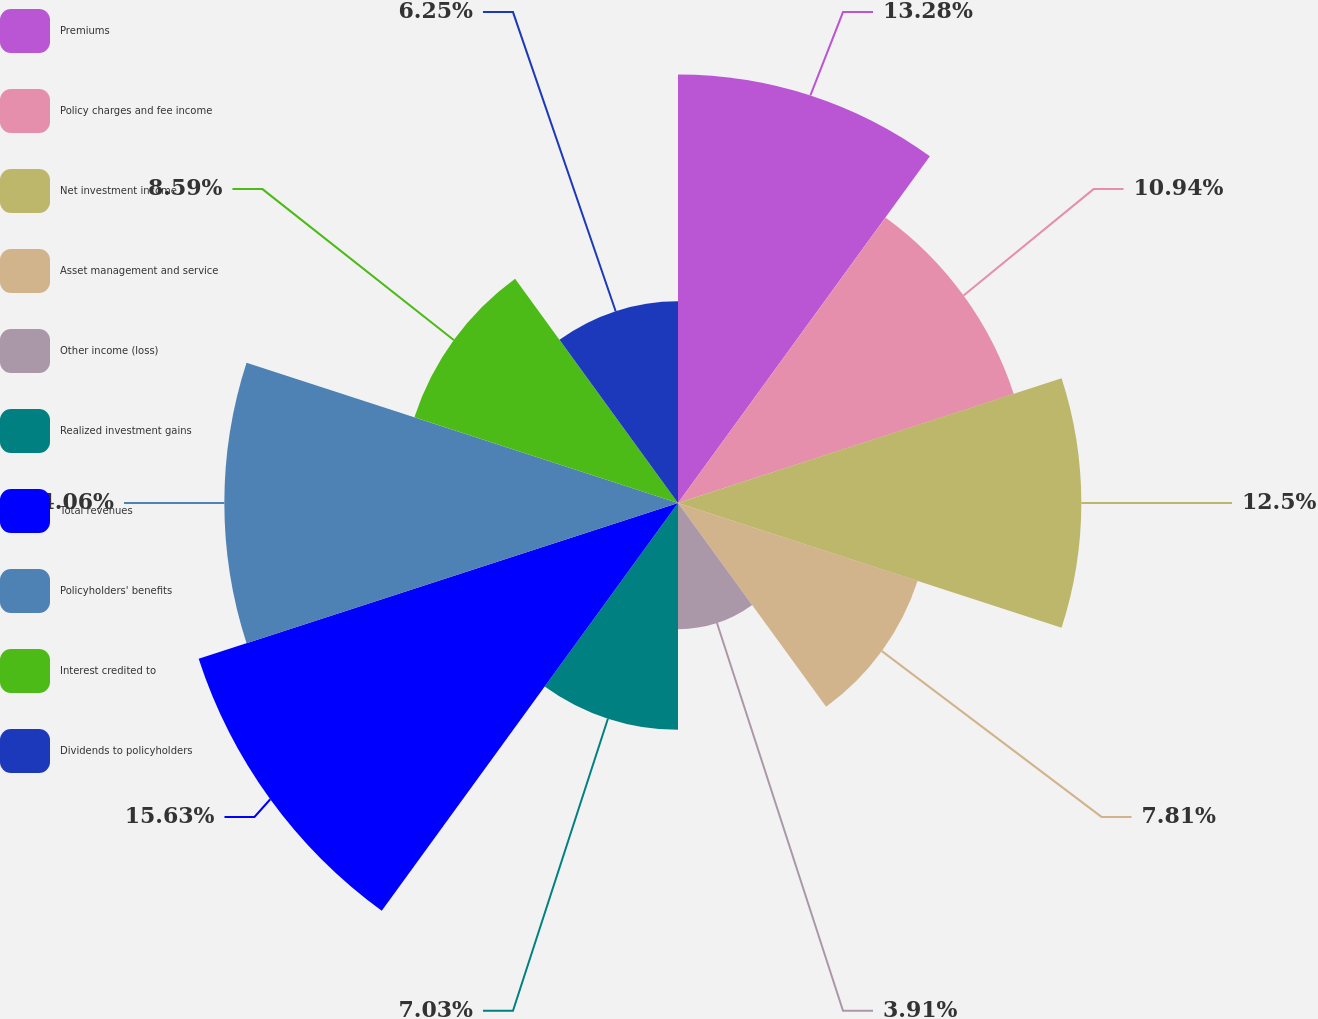Convert chart to OTSL. <chart><loc_0><loc_0><loc_500><loc_500><pie_chart><fcel>Premiums<fcel>Policy charges and fee income<fcel>Net investment income<fcel>Asset management and service<fcel>Other income (loss)<fcel>Realized investment gains<fcel>Total revenues<fcel>Policyholders' benefits<fcel>Interest credited to<fcel>Dividends to policyholders<nl><fcel>13.28%<fcel>10.94%<fcel>12.5%<fcel>7.81%<fcel>3.91%<fcel>7.03%<fcel>15.62%<fcel>14.06%<fcel>8.59%<fcel>6.25%<nl></chart> 